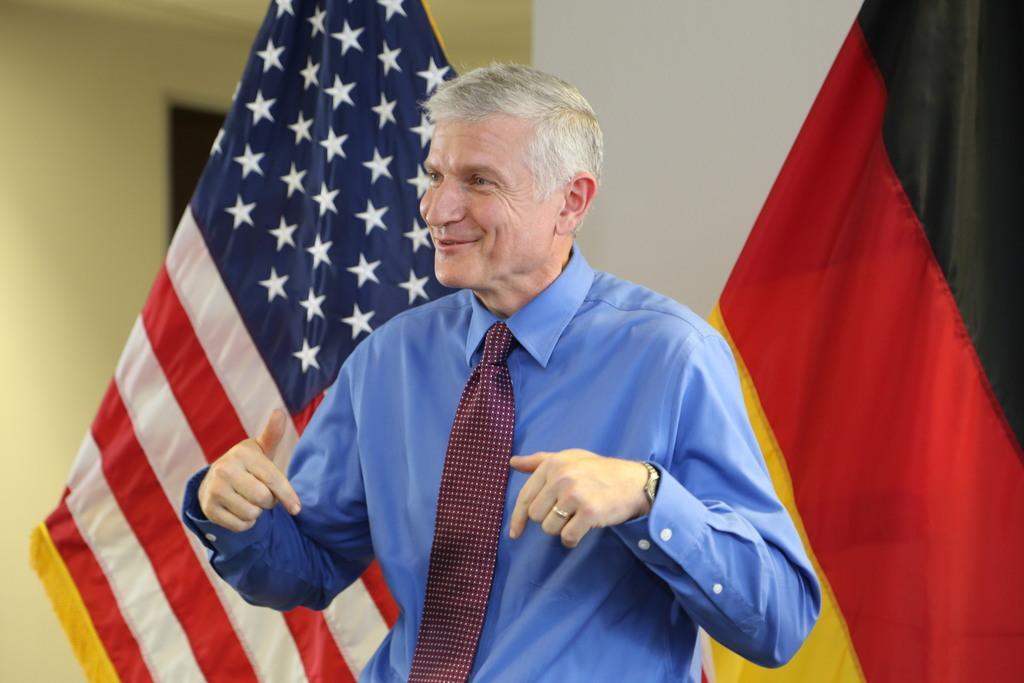Can you describe this image briefly? In front of the image there is a person with a smile on his face, behind the person there are flags, behind the flags there is a door and walls. 